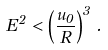<formula> <loc_0><loc_0><loc_500><loc_500>E ^ { 2 } < \left ( \frac { u _ { 0 } } { R } \right ) ^ { 3 } \, .</formula> 